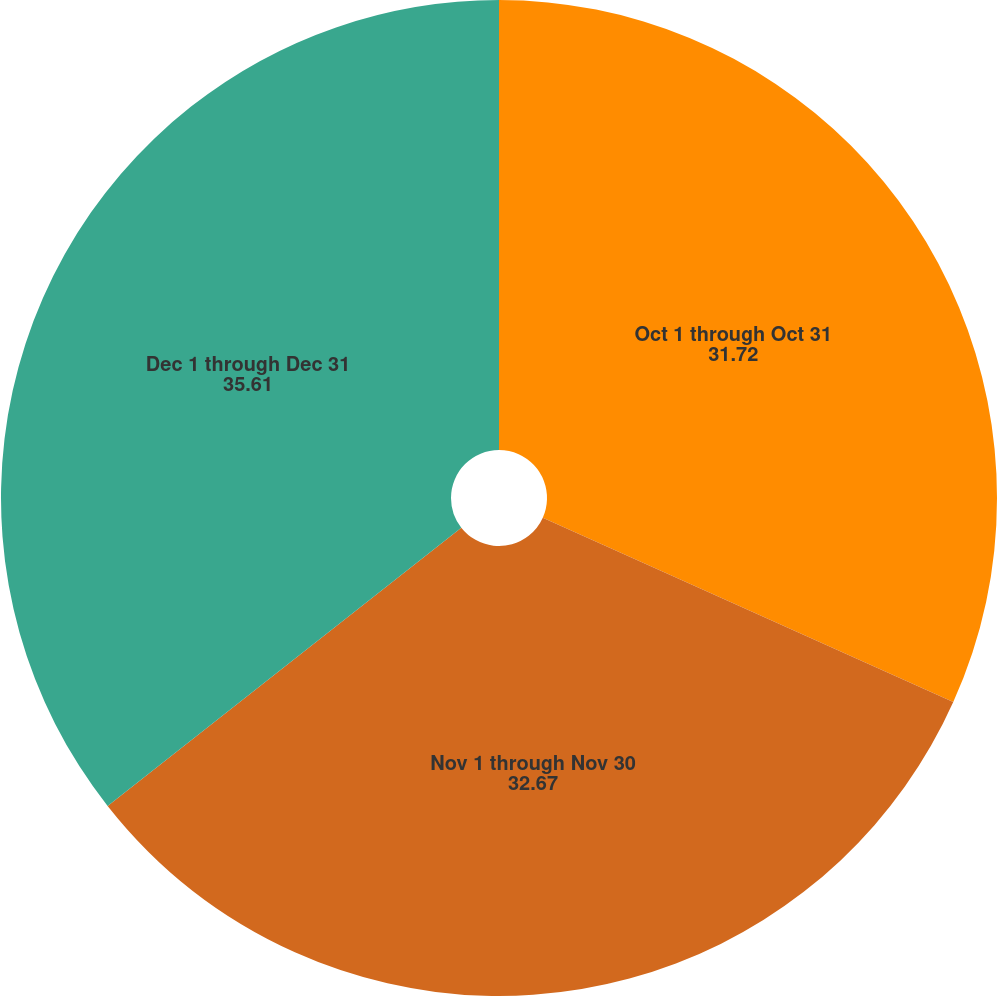Convert chart. <chart><loc_0><loc_0><loc_500><loc_500><pie_chart><fcel>Oct 1 through Oct 31<fcel>Nov 1 through Nov 30<fcel>Dec 1 through Dec 31<nl><fcel>31.72%<fcel>32.67%<fcel>35.61%<nl></chart> 